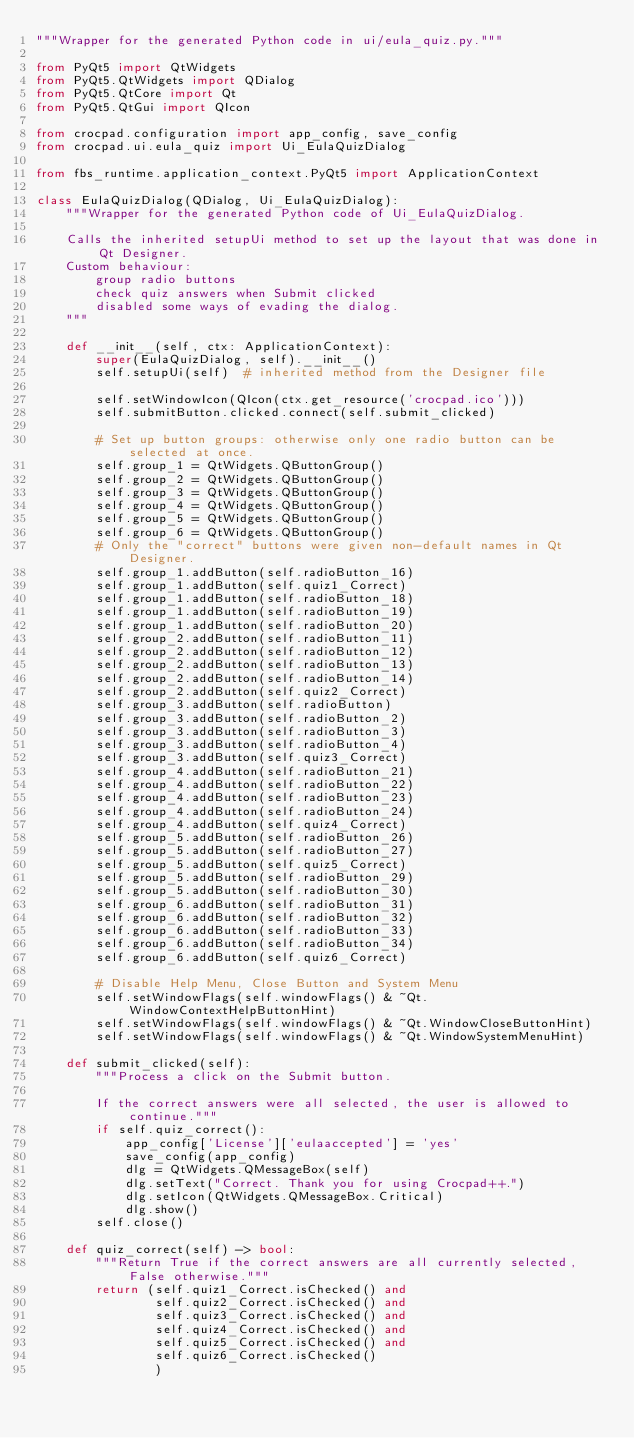Convert code to text. <code><loc_0><loc_0><loc_500><loc_500><_Python_>"""Wrapper for the generated Python code in ui/eula_quiz.py."""

from PyQt5 import QtWidgets
from PyQt5.QtWidgets import QDialog
from PyQt5.QtCore import Qt
from PyQt5.QtGui import QIcon

from crocpad.configuration import app_config, save_config
from crocpad.ui.eula_quiz import Ui_EulaQuizDialog

from fbs_runtime.application_context.PyQt5 import ApplicationContext

class EulaQuizDialog(QDialog, Ui_EulaQuizDialog):
    """Wrapper for the generated Python code of Ui_EulaQuizDialog.

    Calls the inherited setupUi method to set up the layout that was done in Qt Designer.
    Custom behaviour:
        group radio buttons
        check quiz answers when Submit clicked
        disabled some ways of evading the dialog.
    """

    def __init__(self, ctx: ApplicationContext):
        super(EulaQuizDialog, self).__init__()
        self.setupUi(self)  # inherited method from the Designer file

        self.setWindowIcon(QIcon(ctx.get_resource('crocpad.ico')))
        self.submitButton.clicked.connect(self.submit_clicked)

        # Set up button groups: otherwise only one radio button can be selected at once.
        self.group_1 = QtWidgets.QButtonGroup()
        self.group_2 = QtWidgets.QButtonGroup()
        self.group_3 = QtWidgets.QButtonGroup()
        self.group_4 = QtWidgets.QButtonGroup()
        self.group_5 = QtWidgets.QButtonGroup()
        self.group_6 = QtWidgets.QButtonGroup()
        # Only the "correct" buttons were given non-default names in Qt Designer.
        self.group_1.addButton(self.radioButton_16)
        self.group_1.addButton(self.quiz1_Correct)
        self.group_1.addButton(self.radioButton_18)
        self.group_1.addButton(self.radioButton_19)
        self.group_1.addButton(self.radioButton_20)
        self.group_2.addButton(self.radioButton_11)
        self.group_2.addButton(self.radioButton_12)
        self.group_2.addButton(self.radioButton_13)
        self.group_2.addButton(self.radioButton_14)
        self.group_2.addButton(self.quiz2_Correct)
        self.group_3.addButton(self.radioButton)
        self.group_3.addButton(self.radioButton_2)
        self.group_3.addButton(self.radioButton_3)
        self.group_3.addButton(self.radioButton_4)
        self.group_3.addButton(self.quiz3_Correct)
        self.group_4.addButton(self.radioButton_21)
        self.group_4.addButton(self.radioButton_22)
        self.group_4.addButton(self.radioButton_23)
        self.group_4.addButton(self.radioButton_24)
        self.group_4.addButton(self.quiz4_Correct)
        self.group_5.addButton(self.radioButton_26)
        self.group_5.addButton(self.radioButton_27)
        self.group_5.addButton(self.quiz5_Correct)
        self.group_5.addButton(self.radioButton_29)
        self.group_5.addButton(self.radioButton_30)
        self.group_6.addButton(self.radioButton_31)
        self.group_6.addButton(self.radioButton_32)
        self.group_6.addButton(self.radioButton_33)
        self.group_6.addButton(self.radioButton_34)
        self.group_6.addButton(self.quiz6_Correct)

        # Disable Help Menu, Close Button and System Menu
        self.setWindowFlags(self.windowFlags() & ~Qt.WindowContextHelpButtonHint)
        self.setWindowFlags(self.windowFlags() & ~Qt.WindowCloseButtonHint)
        self.setWindowFlags(self.windowFlags() & ~Qt.WindowSystemMenuHint)

    def submit_clicked(self):
        """Process a click on the Submit button.

        If the correct answers were all selected, the user is allowed to continue."""
        if self.quiz_correct():
            app_config['License']['eulaaccepted'] = 'yes'
            save_config(app_config)
            dlg = QtWidgets.QMessageBox(self)
            dlg.setText("Correct. Thank you for using Crocpad++.")
            dlg.setIcon(QtWidgets.QMessageBox.Critical)
            dlg.show()
        self.close()

    def quiz_correct(self) -> bool:
        """Return True if the correct answers are all currently selected, False otherwise."""
        return (self.quiz1_Correct.isChecked() and
                self.quiz2_Correct.isChecked() and
                self.quiz3_Correct.isChecked() and
                self.quiz4_Correct.isChecked() and
                self.quiz5_Correct.isChecked() and
                self.quiz6_Correct.isChecked()
                )
</code> 